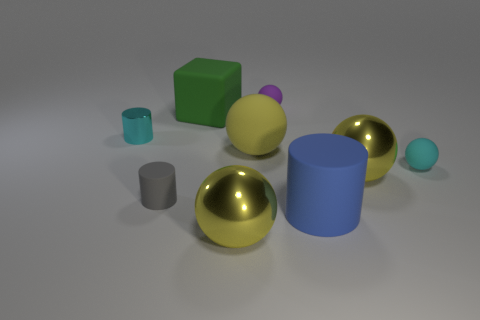Subtract all brown cubes. How many yellow balls are left? 3 Subtract all purple balls. How many balls are left? 4 Add 1 cyan metallic objects. How many objects exist? 10 Subtract all cylinders. How many objects are left? 6 Add 4 tiny metallic things. How many tiny metallic things are left? 5 Add 6 yellow spheres. How many yellow spheres exist? 9 Subtract 0 red spheres. How many objects are left? 9 Subtract all green blocks. Subtract all small purple rubber things. How many objects are left? 7 